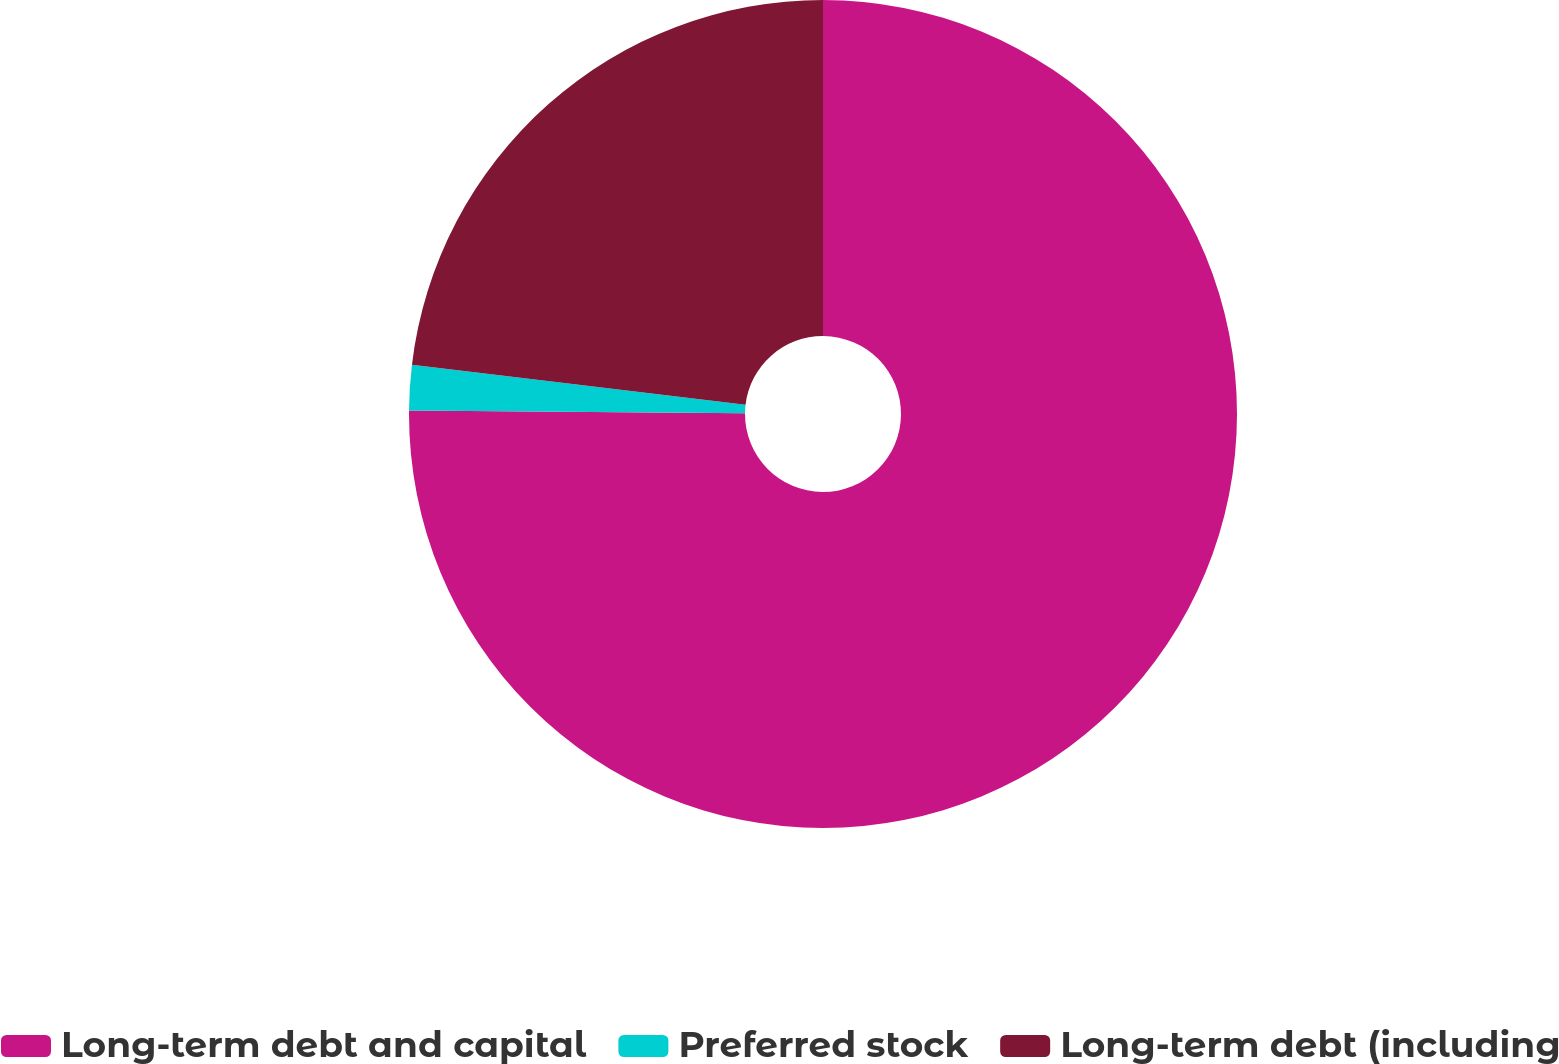Convert chart to OTSL. <chart><loc_0><loc_0><loc_500><loc_500><pie_chart><fcel>Long-term debt and capital<fcel>Preferred stock<fcel>Long-term debt (including<nl><fcel>75.14%<fcel>1.77%<fcel>23.1%<nl></chart> 